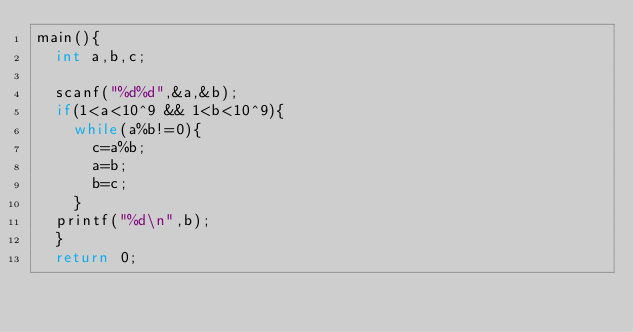<code> <loc_0><loc_0><loc_500><loc_500><_C_>main(){
  int a,b,c;
  
  scanf("%d%d",&a,&b);
  if(1<a<10^9 && 1<b<10^9){
    while(a%b!=0){
      c=a%b;
      a=b;
      b=c;
    }
  printf("%d\n",b);
  }
  return 0;</code> 